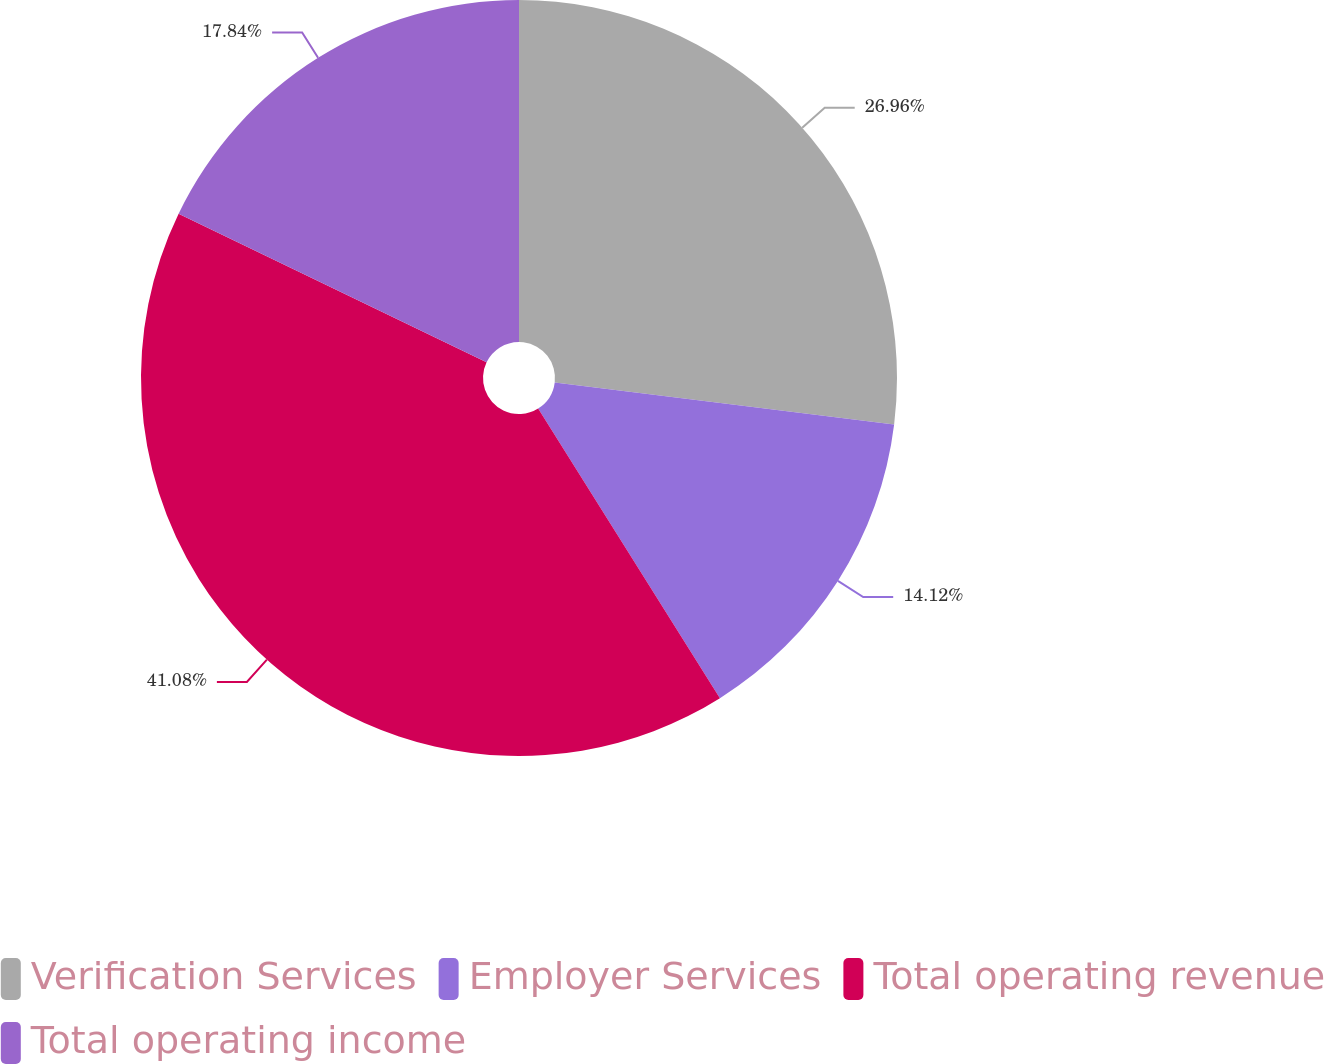Convert chart to OTSL. <chart><loc_0><loc_0><loc_500><loc_500><pie_chart><fcel>Verification Services<fcel>Employer Services<fcel>Total operating revenue<fcel>Total operating income<nl><fcel>26.96%<fcel>14.12%<fcel>41.08%<fcel>17.84%<nl></chart> 